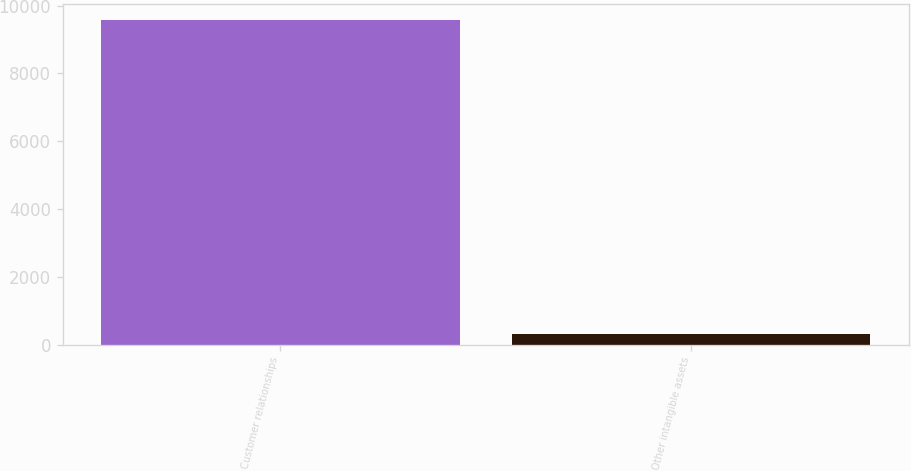Convert chart. <chart><loc_0><loc_0><loc_500><loc_500><bar_chart><fcel>Customer relationships<fcel>Other intangible assets<nl><fcel>9565<fcel>317<nl></chart> 